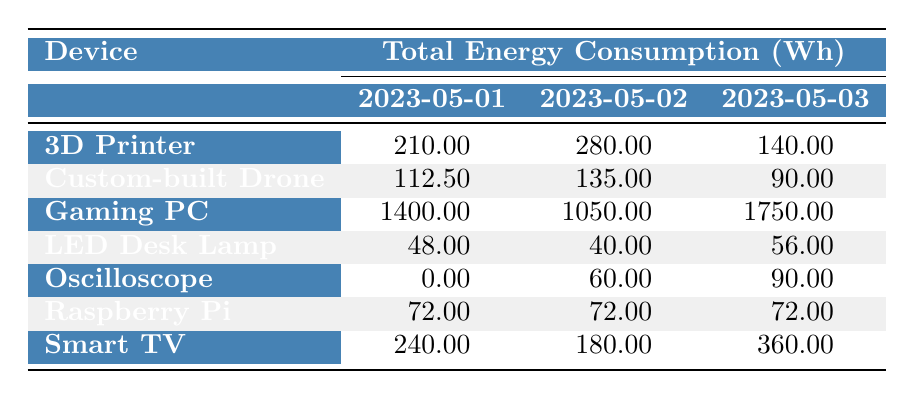What is the total energy consumption of the Gaming PC on May 2, 2023? Referring to the table, the energy consumption for the Gaming PC on May 2, 2023, is listed as 1050.00 Wh.
Answer: 1050.00 Wh How much energy did the Smart TV consume on May 1, 2023, compared to May 3, 2023? The Smart TV consumed 240.00 Wh on May 1 and 360.00 Wh on May 3. The difference is 360.00 Wh - 240.00 Wh = 120.00 Wh.
Answer: 120.00 Wh Is the total energy consumption of the Raspberry Pi the same across all three dates? The table shows that the Raspberry Pi consumed 72.00 Wh on all three dates (May 1, 2, and 3). Thus, it is true that the consumption is the same.
Answer: Yes What is the average energy consumption of the Custom-built Drone over the three days? First, we sum the energy values: 112.50 Wh (May 1) + 135.00 Wh (May 2) + 90.00 Wh (May 3) = 337.50 Wh. Then, dividing by 3 gives the average: 337.50 Wh / 3 = 112.50 Wh.
Answer: 112.50 Wh Which device had the highest total energy consumption on May 3, 2023? On May 3, the Gaming PC had the highest consumption at 1750.00 Wh, followed by the Smart TV at 360.00 Wh. Therefore, the Gaming PC has the highest total consumption on that day.
Answer: Gaming PC 